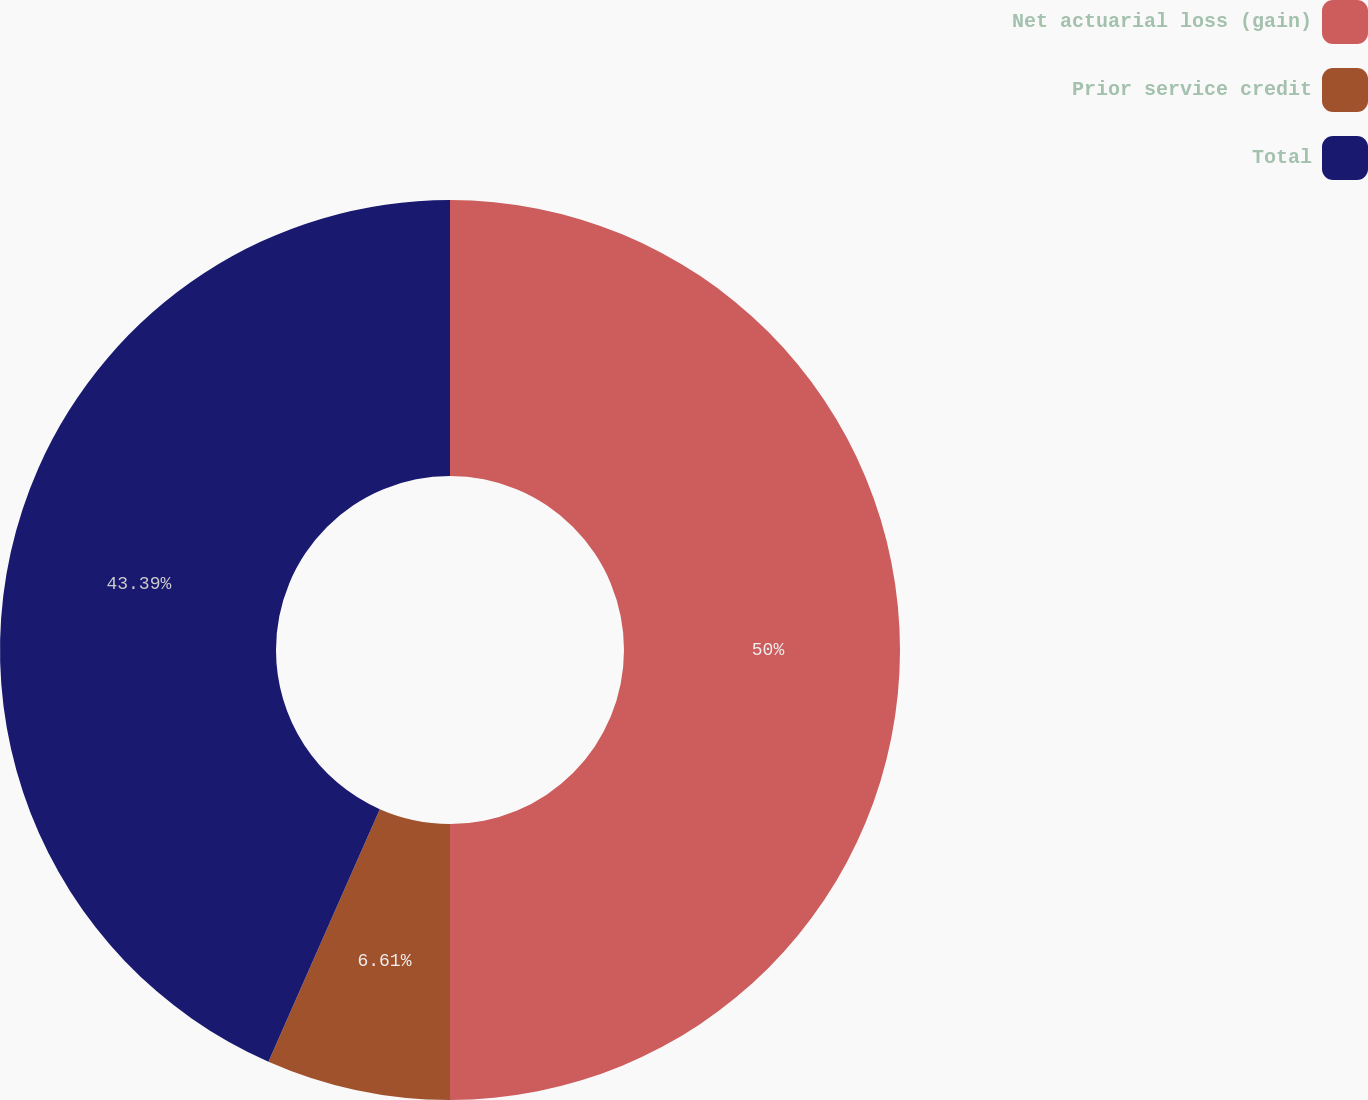Convert chart to OTSL. <chart><loc_0><loc_0><loc_500><loc_500><pie_chart><fcel>Net actuarial loss (gain)<fcel>Prior service credit<fcel>Total<nl><fcel>50.0%<fcel>6.61%<fcel>43.39%<nl></chart> 